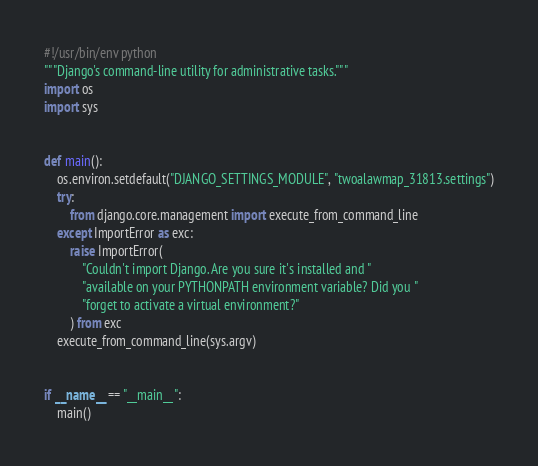Convert code to text. <code><loc_0><loc_0><loc_500><loc_500><_Python_>#!/usr/bin/env python
"""Django's command-line utility for administrative tasks."""
import os
import sys


def main():
    os.environ.setdefault("DJANGO_SETTINGS_MODULE", "twoalawmap_31813.settings")
    try:
        from django.core.management import execute_from_command_line
    except ImportError as exc:
        raise ImportError(
            "Couldn't import Django. Are you sure it's installed and "
            "available on your PYTHONPATH environment variable? Did you "
            "forget to activate a virtual environment?"
        ) from exc
    execute_from_command_line(sys.argv)


if __name__ == "__main__":
    main()
</code> 